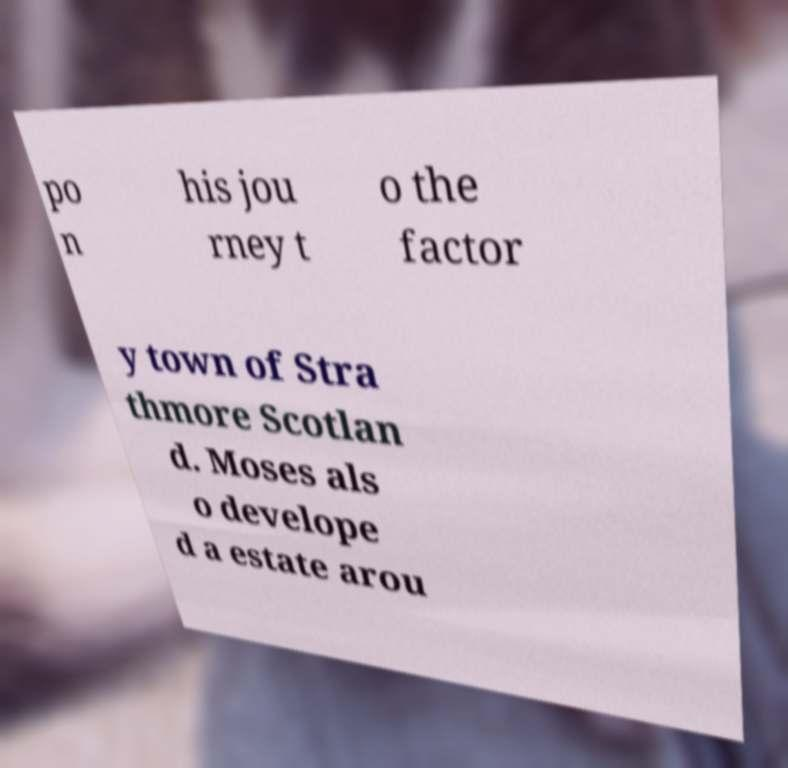Can you read and provide the text displayed in the image?This photo seems to have some interesting text. Can you extract and type it out for me? po n his jou rney t o the factor y town of Stra thmore Scotlan d. Moses als o develope d a estate arou 